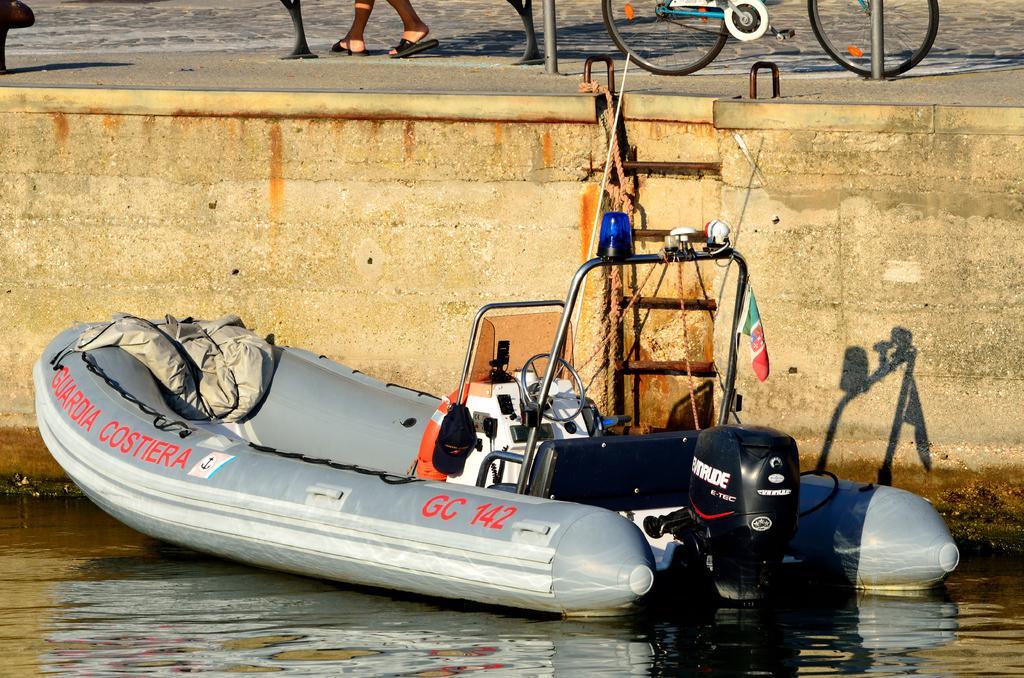Please provide a concise description of this image. In this image, I can see an inflatable boat on the water. This is an engine, which is attached to a boat. I can see a wall. This looks like a ladder. At the top of the image, I can see a person's legs. I think this is a bicycle. These are the poles. 